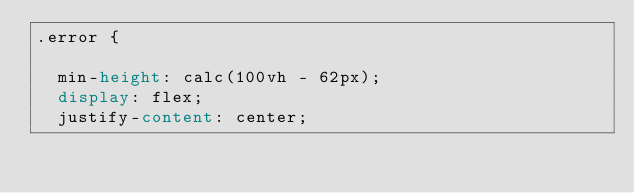<code> <loc_0><loc_0><loc_500><loc_500><_CSS_>.error {
  
  min-height: calc(100vh - 62px);
  display: flex;
  justify-content: center;</code> 